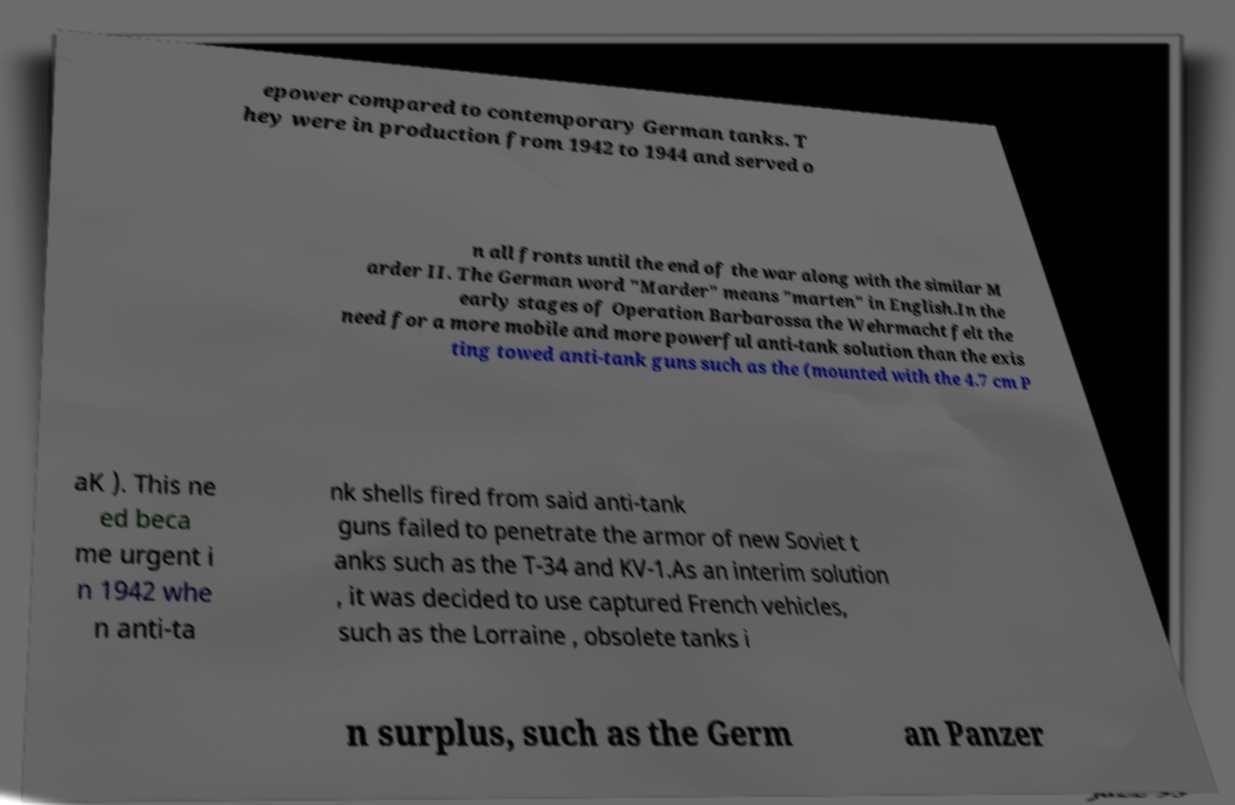What messages or text are displayed in this image? I need them in a readable, typed format. epower compared to contemporary German tanks. T hey were in production from 1942 to 1944 and served o n all fronts until the end of the war along with the similar M arder II. The German word "Marder" means "marten" in English.In the early stages of Operation Barbarossa the Wehrmacht felt the need for a more mobile and more powerful anti-tank solution than the exis ting towed anti-tank guns such as the (mounted with the 4.7 cm P aK ). This ne ed beca me urgent i n 1942 whe n anti-ta nk shells fired from said anti-tank guns failed to penetrate the armor of new Soviet t anks such as the T-34 and KV-1.As an interim solution , it was decided to use captured French vehicles, such as the Lorraine , obsolete tanks i n surplus, such as the Germ an Panzer 